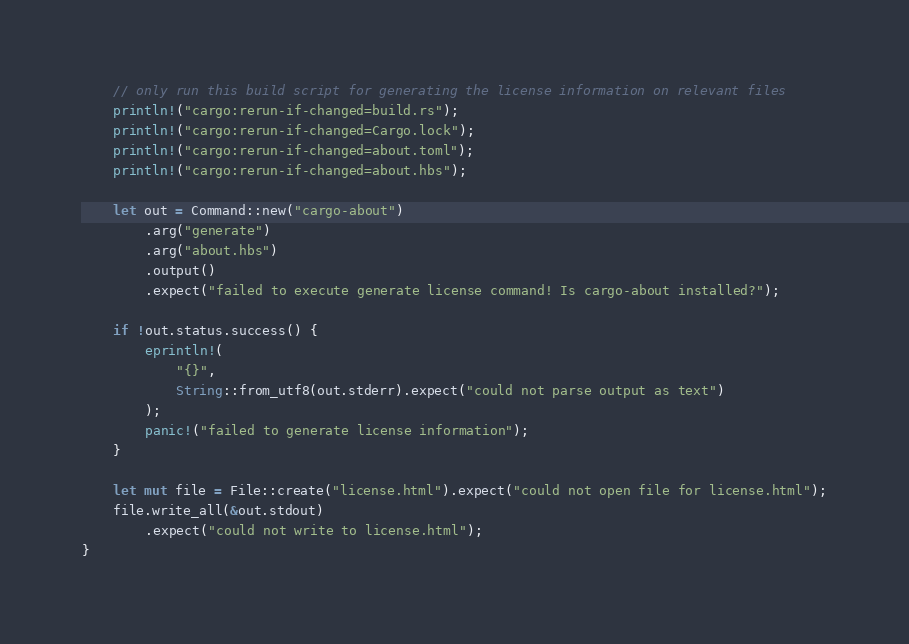Convert code to text. <code><loc_0><loc_0><loc_500><loc_500><_Rust_>    // only run this build script for generating the license information on relevant files
    println!("cargo:rerun-if-changed=build.rs");
    println!("cargo:rerun-if-changed=Cargo.lock");
    println!("cargo:rerun-if-changed=about.toml");
    println!("cargo:rerun-if-changed=about.hbs");

    let out = Command::new("cargo-about")
        .arg("generate")
        .arg("about.hbs")
        .output()
        .expect("failed to execute generate license command! Is cargo-about installed?");

    if !out.status.success() {
        eprintln!(
            "{}",
            String::from_utf8(out.stderr).expect("could not parse output as text")
        );
        panic!("failed to generate license information");
    }

    let mut file = File::create("license.html").expect("could not open file for license.html");
    file.write_all(&out.stdout)
        .expect("could not write to license.html");
}
</code> 